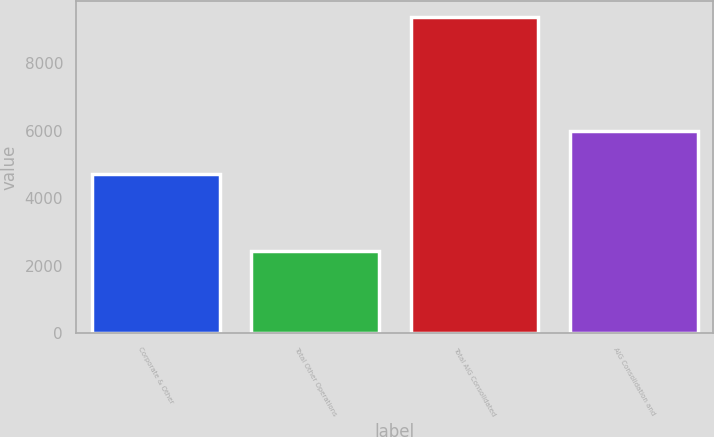Convert chart to OTSL. <chart><loc_0><loc_0><loc_500><loc_500><bar_chart><fcel>Corporate & Other<fcel>Total Other Operations<fcel>Total AIG Consolidated<fcel>AIG Consolidation and<nl><fcel>4706<fcel>2449<fcel>9368<fcel>5988<nl></chart> 